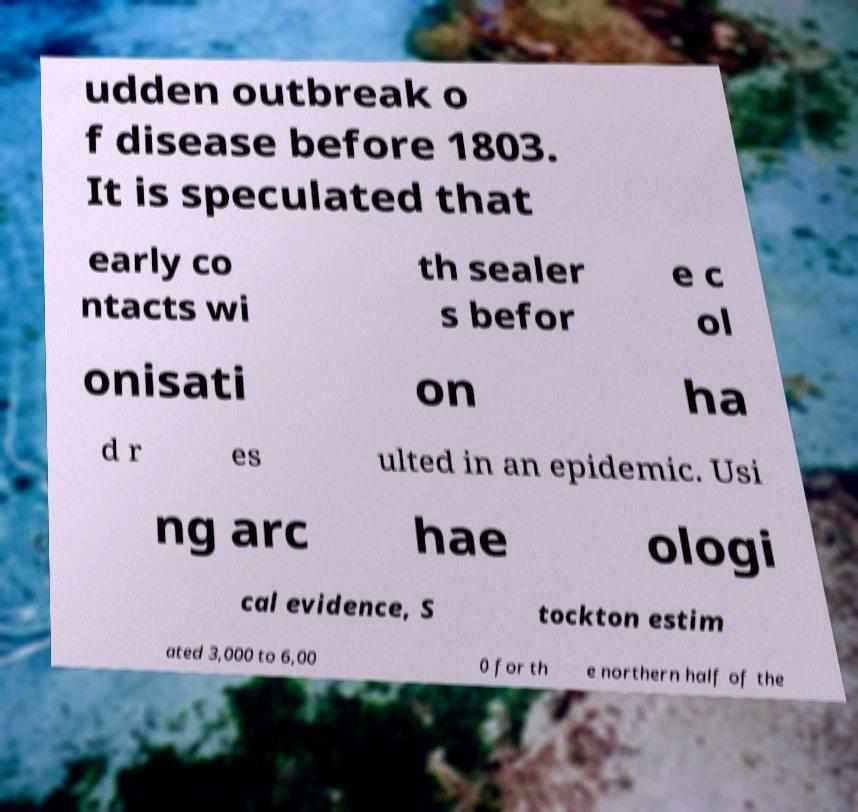What messages or text are displayed in this image? I need them in a readable, typed format. udden outbreak o f disease before 1803. It is speculated that early co ntacts wi th sealer s befor e c ol onisati on ha d r es ulted in an epidemic. Usi ng arc hae ologi cal evidence, S tockton estim ated 3,000 to 6,00 0 for th e northern half of the 